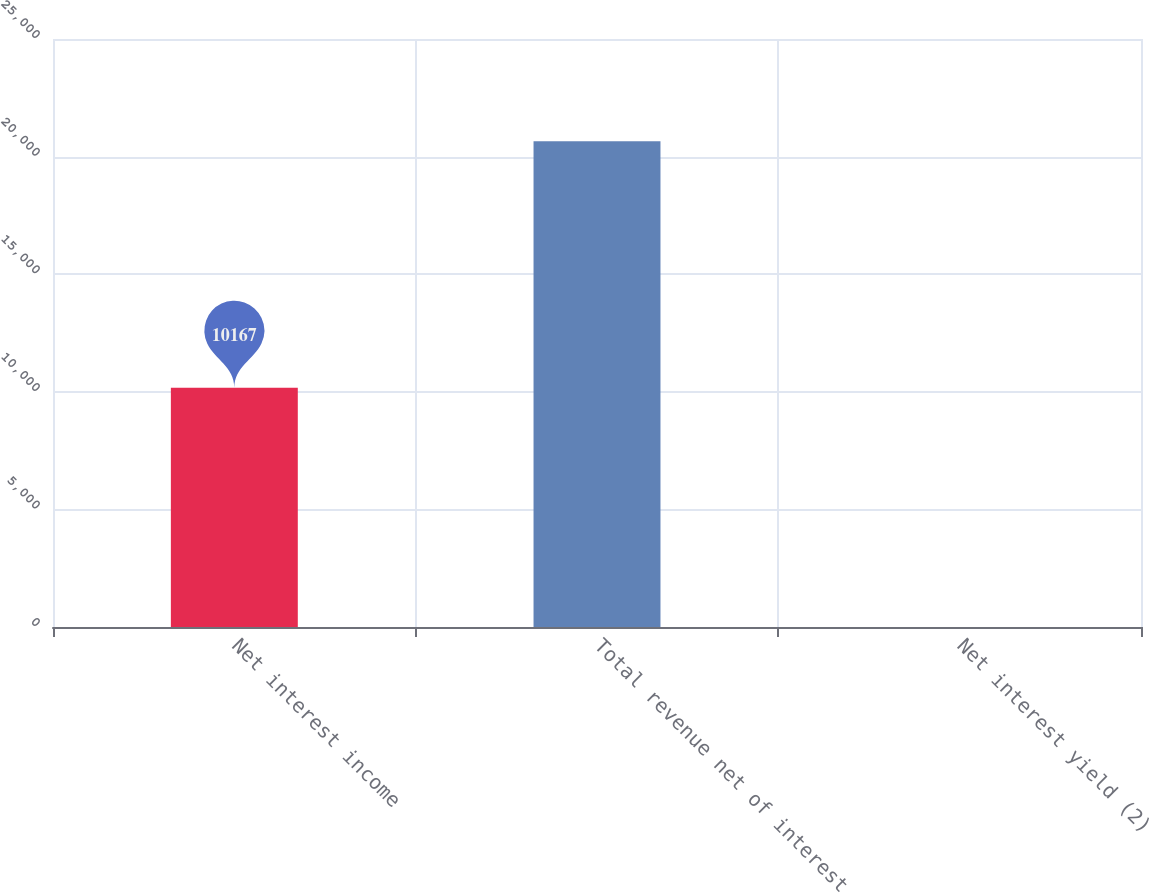<chart> <loc_0><loc_0><loc_500><loc_500><bar_chart><fcel>Net interest income<fcel>Total revenue net of interest<fcel>Net interest yield (2)<nl><fcel>10167<fcel>20657<fcel>2.32<nl></chart> 